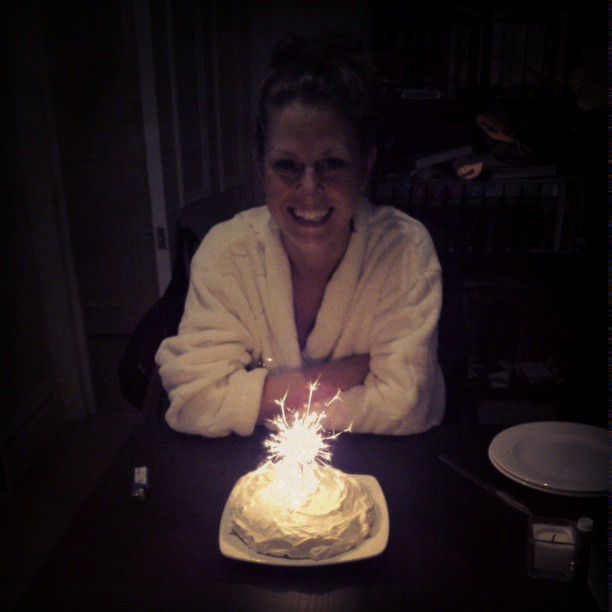What number of sparklers are in this cake? The birthday cake in the image has one sparkler. It adds a bright, festive touch to the celebration! 